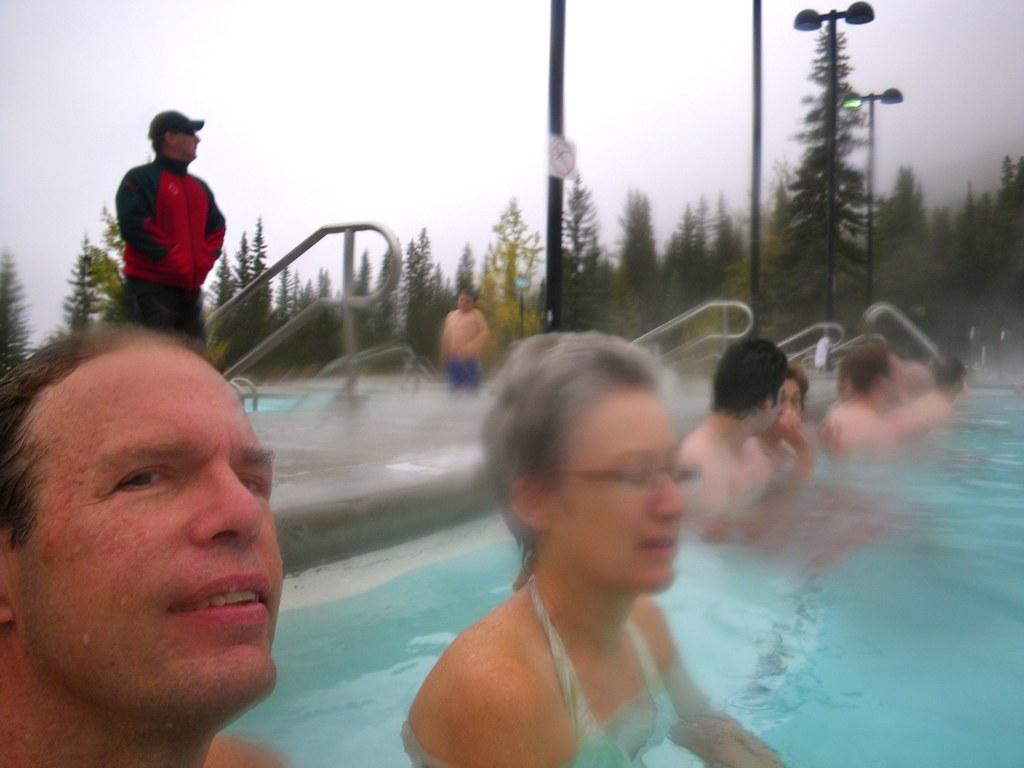What are the people in the image doing? There are people in the water, which suggests they might be swimming or engaging in water activities. Are there any other people in the image? Yes, there are people standing outside and watching. What can be seen in the background of the image? Trees are visible around the area. What type of calendar is hanging on the tree in the image? There is no calendar present in the image; it features people in the water and trees in the background. 